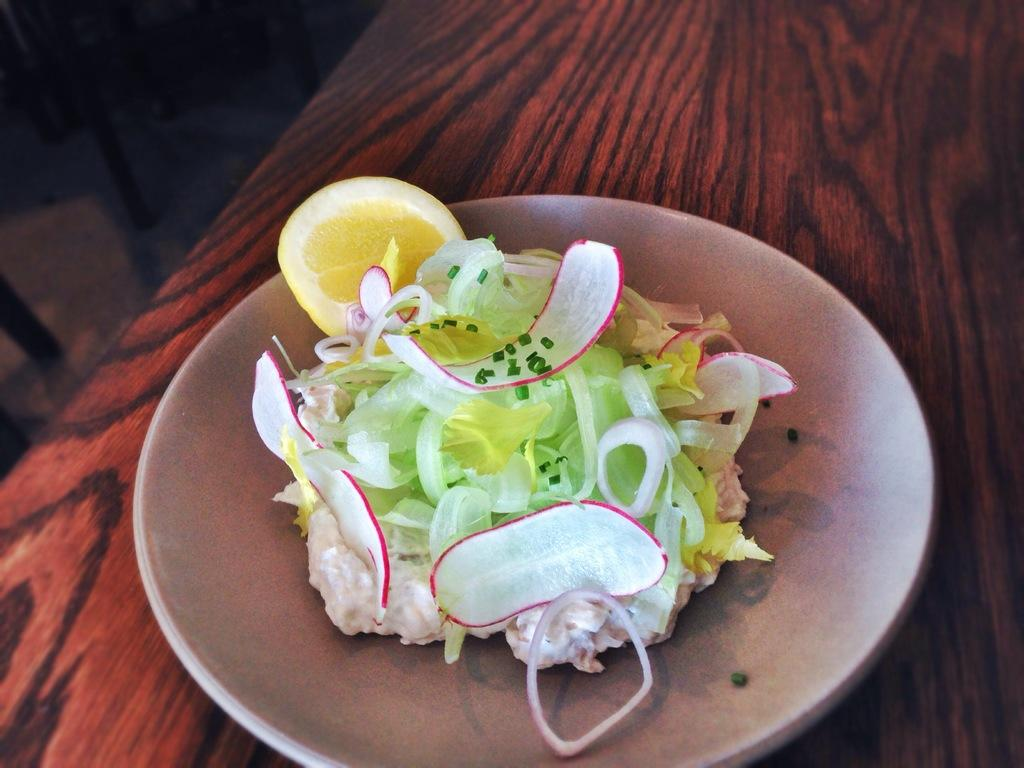What is on the white plate in the image? There is a food item on a white plate in the image. What type of surface is visible in the image? There is a wooden surface in the image. What type of plastic material can be seen in the image? There is no plastic material present in the image. What emotion can be observed on the food item in the image? The food item does not have emotions, as it is an inanimate object. 